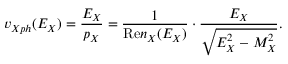<formula> <loc_0><loc_0><loc_500><loc_500>v _ { X p h } ( E _ { X } ) = \frac { E _ { X } } { p _ { X } } = \frac { 1 } { R e n _ { X } ( E _ { X } ) } \cdot \frac { E _ { X } } { \sqrt { E _ { X } ^ { 2 } - M _ { X } ^ { 2 } } } .</formula> 